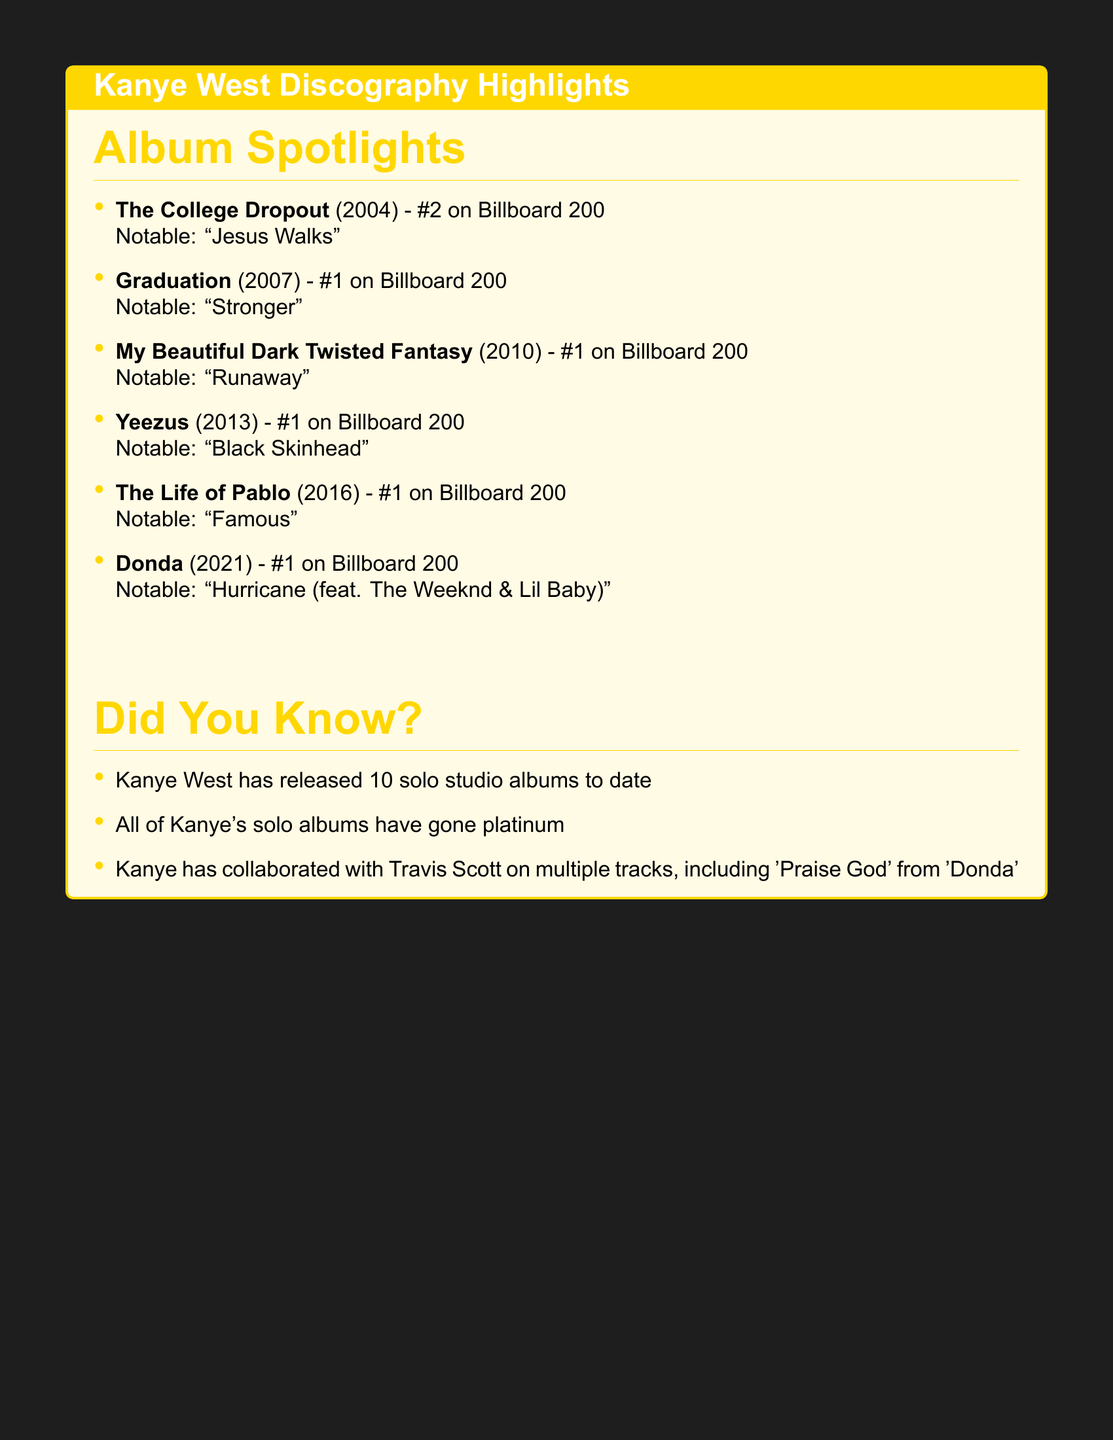What is the release date of "The College Dropout"? The release date for "The College Dropout" is specified in the document as February 10, 2004.
Answer: February 10, 2004 Which notable track is associated with "Graduation"? The document highlights "Stronger" as the notable track for the album "Graduation."
Answer: Stronger What chart position did "Yeezus" achieve? The document states that "Yeezus" reached the position of #1 on the Billboard 200.
Answer: #1 on Billboard 200 How many studio albums has Kanye West released? The document mentions that Kanye West has released 10 solo studio albums to date.
Answer: 10 Which album features the track "Hurricane"? According to the document, the track "Hurricane" is from the album "Donda."
Answer: Donda What was the notable track for "My Beautiful Dark Twisted Fantasy"? The notable track for "My Beautiful Dark Twisted Fantasy" is listed as "Runaway" in the document.
Answer: Runaway Which album was released on June 18, 2013? The document states that "Yeezus" was released on June 18, 2013.
Answer: Yeezus What collaboration does Kanye have with Travis Scott? The document notes that Kanye has collaborated with Travis Scott on the track "Praise God" from "Donda."
Answer: Praise God What is the first album listed in the document? The first album mentioned in the document is "The College Dropout."
Answer: The College Dropout 